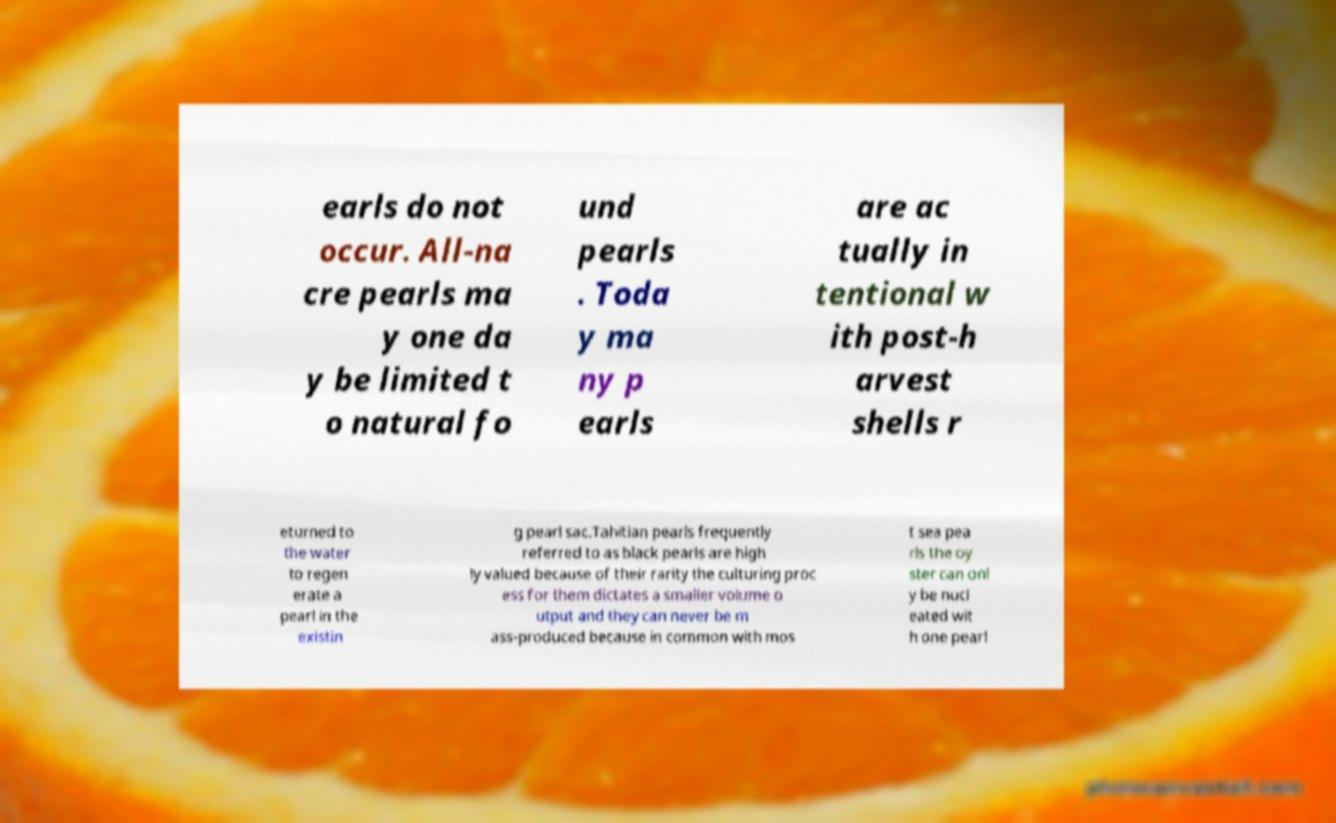I need the written content from this picture converted into text. Can you do that? earls do not occur. All-na cre pearls ma y one da y be limited t o natural fo und pearls . Toda y ma ny p earls are ac tually in tentional w ith post-h arvest shells r eturned to the water to regen erate a pearl in the existin g pearl sac.Tahitian pearls frequently referred to as black pearls are high ly valued because of their rarity the culturing proc ess for them dictates a smaller volume o utput and they can never be m ass-produced because in common with mos t sea pea rls the oy ster can onl y be nucl eated wit h one pearl 